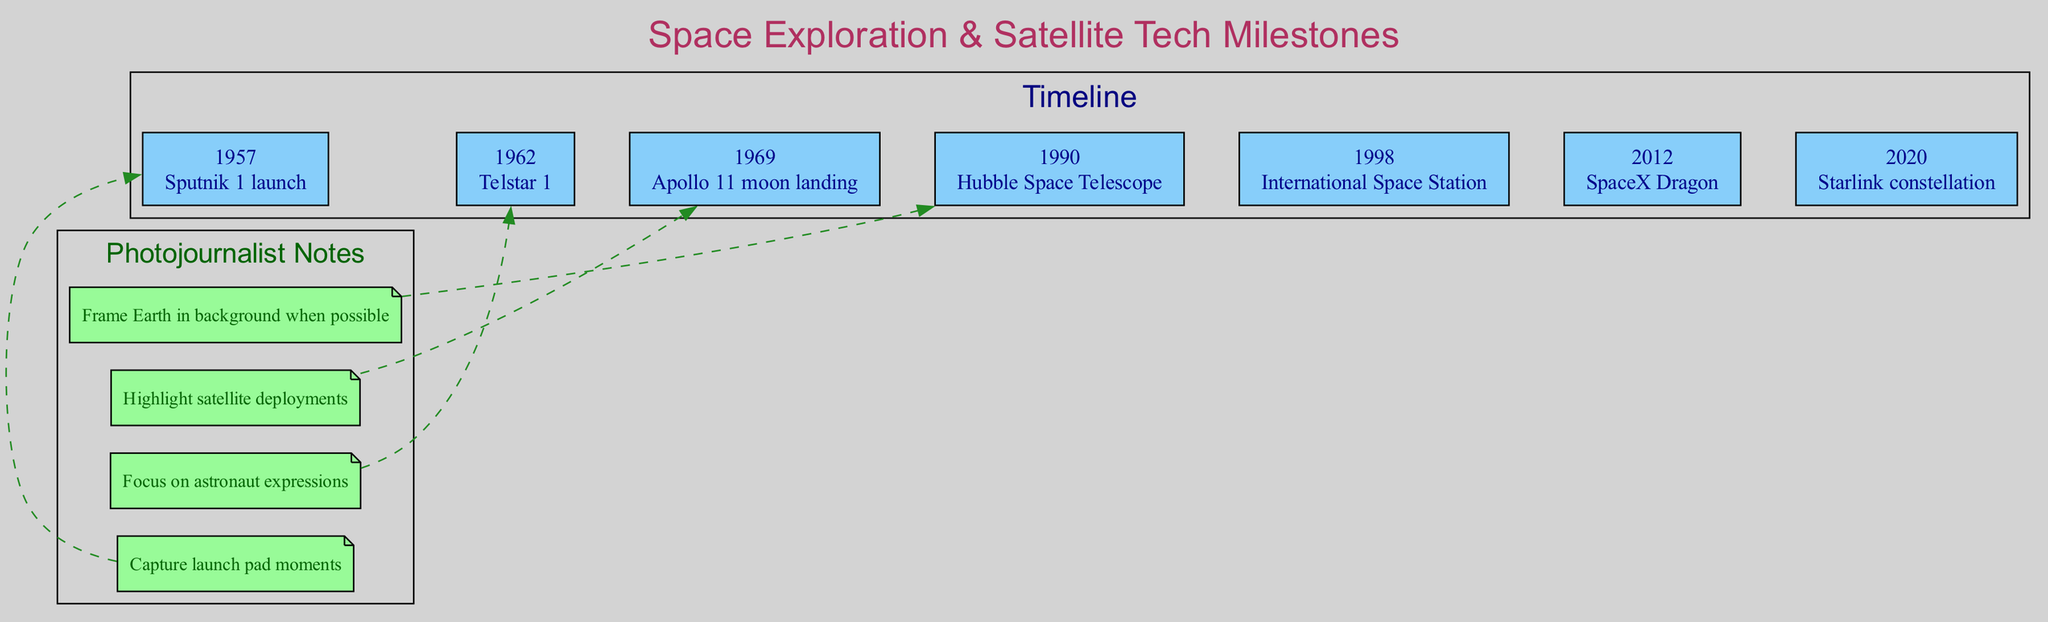What year did Sputnik 1 launch? According to the timeline provided, Sputnik 1 was launched in 1957. This is directly stated as the first event in the timeline.
Answer: 1957 What significant milestone occurred in 1969? Referring to the timeline, the event listed for 1969 is the Apollo 11 moon landing, which is the first instance of humans landing on the moon.
Answer: Apollo 11 moon landing How many events are listed on the timeline? By counting each event in the timeline, there are a total of seven significant milestones detailed, from 1957 until 2020.
Answer: 7 What was the first active communications satellite? The timeline notes that Telstar 1, launched in 1962, is recognized as the first active communications satellite.
Answer: Telstar 1 Which event marks the beginning of global satellite internet coverage? From the timeline, the event that marks the start of global satellite internet coverage is the launch of the Starlink constellation in 2020.
Answer: Starlink constellation What is the connection between Hubble Space Telescope and the timeline of space exploration? The timeline specifically mentions the Hubble Space Telescope as a revolutionary space-based observatory launched in 1990, showcasing its importance in space exploration advancements.
Answer: Revolutionary space-based observatory How many photojournalist notes are mentioned in the diagram? Upon reviewing the section on photojournalist notes, there are four distinct notes provided that guide photographic focuses during events.
Answer: 4 What important space structure was launched in 1998? According to the timeline, the International Space Station represents a significant milestone, noted specifically as the largest artificial object in orbit, and it was launched in 1998.
Answer: International Space Station How does the timeline visually connect events to photojournalist notes? Analyzing the diagram, each of the photojournalist notes connects to the timeline events through dashed edges, indicating a conceptual link, often rotating through the timeline instances.
Answer: Dashed edges connecting notes to events 